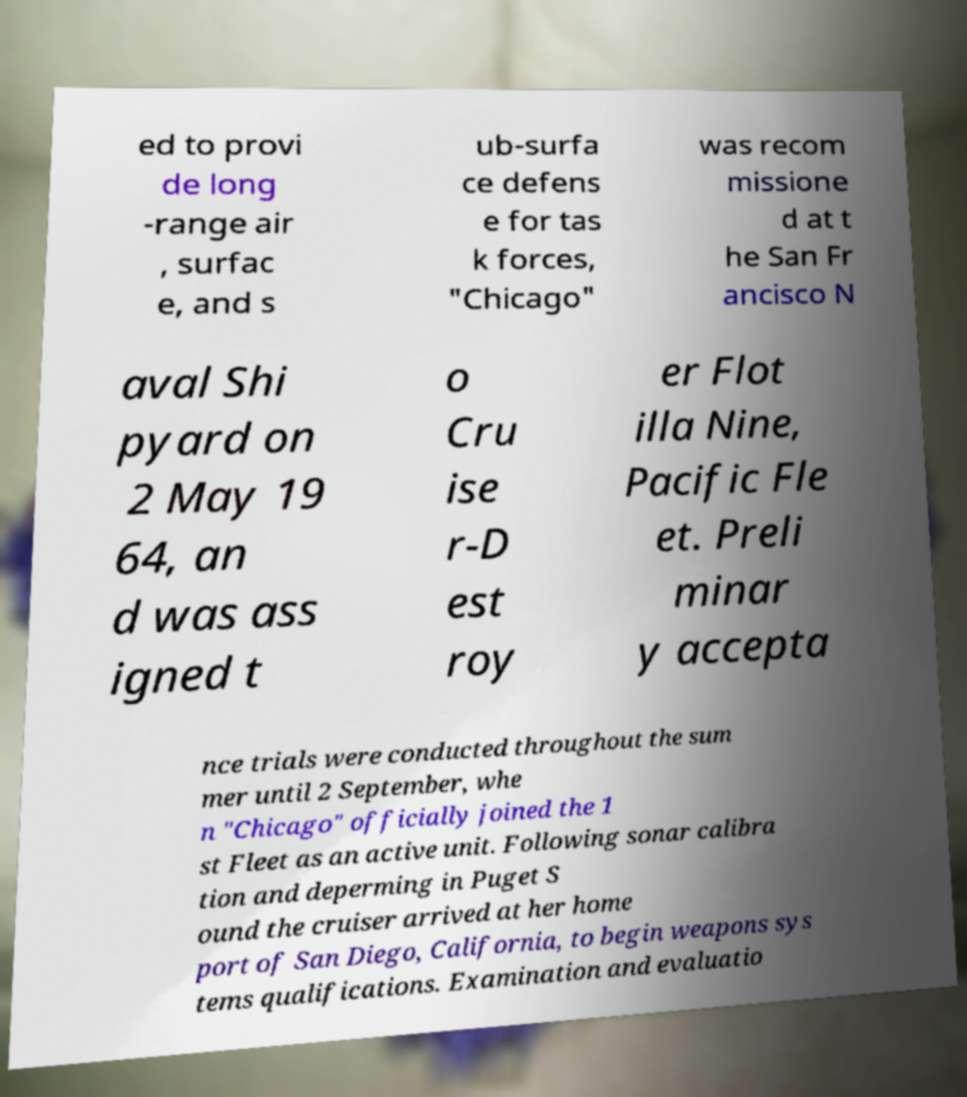Please read and relay the text visible in this image. What does it say? ed to provi de long -range air , surfac e, and s ub-surfa ce defens e for tas k forces, "Chicago" was recom missione d at t he San Fr ancisco N aval Shi pyard on 2 May 19 64, an d was ass igned t o Cru ise r-D est roy er Flot illa Nine, Pacific Fle et. Preli minar y accepta nce trials were conducted throughout the sum mer until 2 September, whe n "Chicago" officially joined the 1 st Fleet as an active unit. Following sonar calibra tion and deperming in Puget S ound the cruiser arrived at her home port of San Diego, California, to begin weapons sys tems qualifications. Examination and evaluatio 